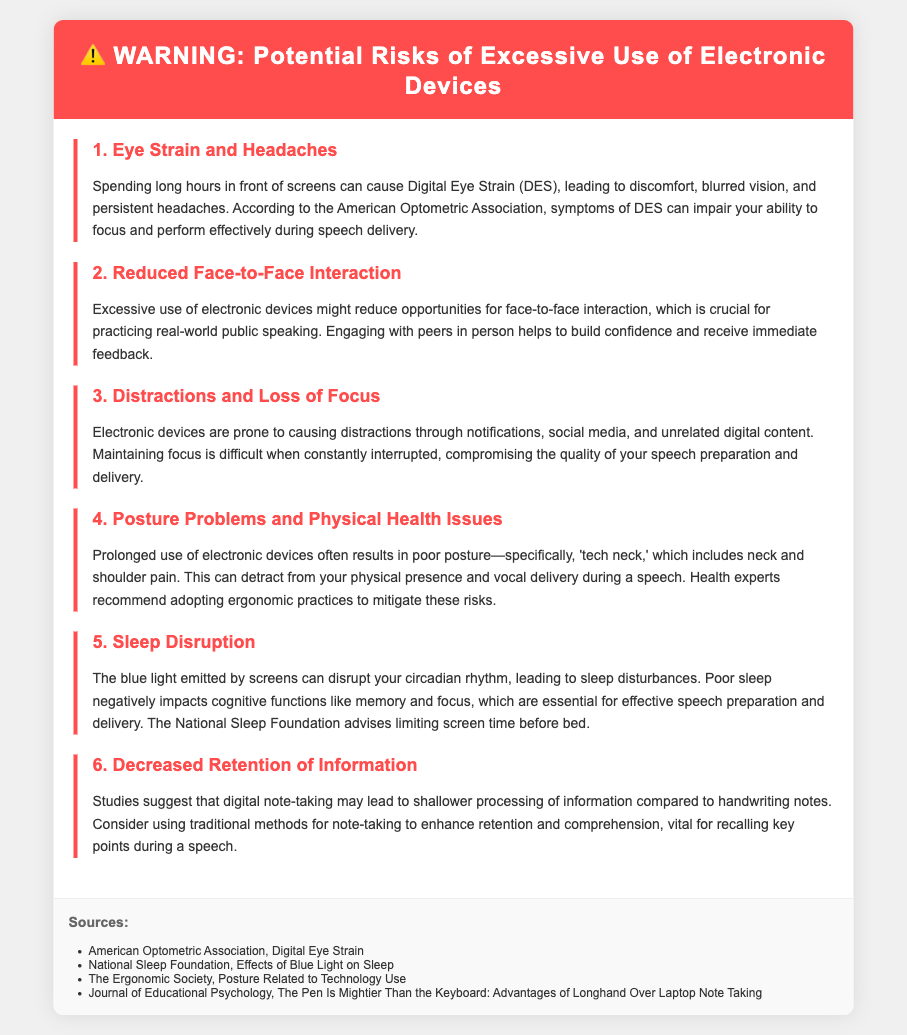What are the symptoms of Digital Eye Strain? The document lists discomfort, blurred vision, and persistent headaches as symptoms of Digital Eye Strain.
Answer: discomfort, blurred vision, and persistent headaches What issue does excessive device use cause regarding interactions? The document states that excessive use of electronic devices might reduce opportunities for face-to-face interaction.
Answer: Reduced face-to-face interaction What is ‘tech neck’? The document defines ‘tech neck’ as a condition that includes neck and shoulder pain due to prolonged use of electronic devices.
Answer: Neck and shoulder pain What type of light disrupts sleep? The document mentions that blue light emitted by screens disrupts sleep.
Answer: Blue light Which foundation advises limiting screen time before bed? The document cites the National Sleep Foundation as advising to limit screen time before bed.
Answer: National Sleep Foundation What should be used for better retention of information? The document suggests using traditional methods for note-taking to enhance retention and comprehension.
Answer: Traditional methods for note-taking How can distractions impact speech preparation? The document explains that distractions from electronic devices compromise the quality of your speech preparation and delivery.
Answer: Compromise quality What is one physical health issue linked to device use? The document describes poor posture as a physical health issue linked to prolonged use of electronic devices.
Answer: Poor posture 